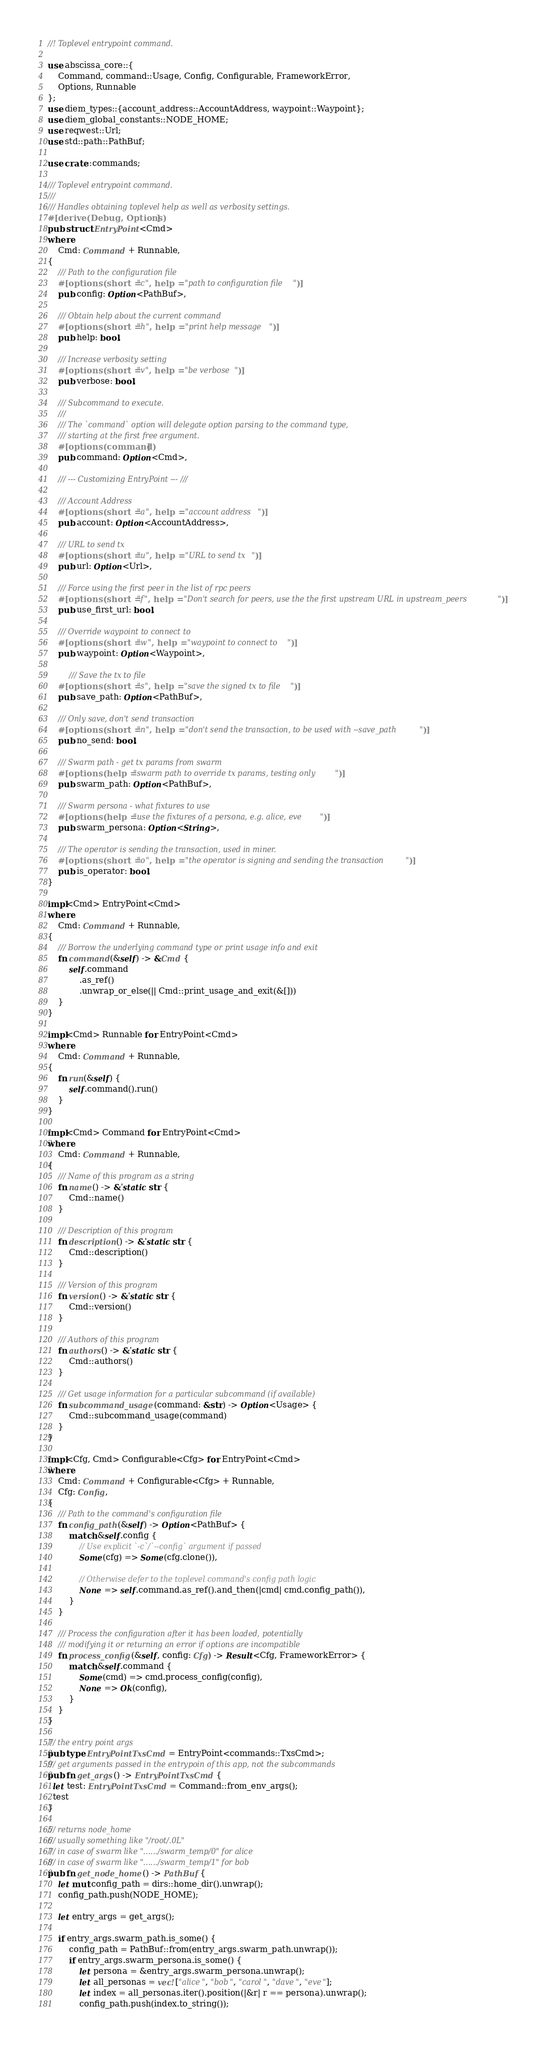Convert code to text. <code><loc_0><loc_0><loc_500><loc_500><_Rust_>//! Toplevel entrypoint command.

use abscissa_core::{
    Command, command::Usage, Config, Configurable, FrameworkError, 
    Options, Runnable    
};
use diem_types::{account_address::AccountAddress, waypoint::Waypoint};
use diem_global_constants::NODE_HOME;
use reqwest::Url;
use std::path::PathBuf;

use crate::commands;

/// Toplevel entrypoint command.
///
/// Handles obtaining toplevel help as well as verbosity settings.
#[derive(Debug, Options)]
pub struct EntryPoint<Cmd>
where
    Cmd: Command + Runnable,
{
    /// Path to the configuration file
    #[options(short = "c", help = "path to configuration file")]
    pub config: Option<PathBuf>,

    /// Obtain help about the current command
    #[options(short = "h", help = "print help message")]
    pub help: bool,

    /// Increase verbosity setting
    #[options(short = "v", help = "be verbose")]
    pub verbose: bool,

    /// Subcommand to execute.
    ///
    /// The `command` option will delegate option parsing to the command type,
    /// starting at the first free argument.
    #[options(command)]
    pub command: Option<Cmd>,

    /// --- Customizing EntryPoint --- ///

    /// Account Address
    #[options(short = "a", help = "account address")]
    pub account: Option<AccountAddress>,

    /// URL to send tx
    #[options(short = "u", help = "URL to send tx")]    
    pub url: Option<Url>,

    /// Force using the first peer in the list of rpc peers
    #[options(short = "f", help = "Don't search for peers, use the the first upstream URL in upstream_peers")]
    pub use_first_url: bool,

    /// Override waypoint to connect to
    #[options(short = "w", help = "waypoint to connect to")]
    pub waypoint: Option<Waypoint>,

        /// Save the tx to file
    #[options(short = "s", help = "save the signed tx to file")]
    pub save_path: Option<PathBuf>,

    /// Only save, don't send transaction
    #[options(short = "n", help = "don't send the transaction, to be used with --save_path")]
    pub no_send: bool,

    /// Swarm path - get tx params from swarm
    #[options(help = "swarm path to override tx params, testing only")]
    pub swarm_path: Option<PathBuf>,

    /// Swarm persona - what fixtures to use
    #[options(help = "use the fixtures of a persona, e.g. alice, eve")]
    pub swarm_persona: Option<String>,

    /// The operator is sending the transaction, used in miner.
    #[options(short = "o", help = "the operator is signing and sending the transaction")]
    pub is_operator: bool,
}

impl<Cmd> EntryPoint<Cmd>
where
    Cmd: Command + Runnable,
{
    /// Borrow the underlying command type or print usage info and exit
    fn command(&self) -> &Cmd {
        self.command
            .as_ref()
            .unwrap_or_else(|| Cmd::print_usage_and_exit(&[]))
    }
}

impl<Cmd> Runnable for EntryPoint<Cmd>
where
    Cmd: Command + Runnable,
{
    fn run(&self) {
        self.command().run()
    }
}

impl<Cmd> Command for EntryPoint<Cmd>
where
    Cmd: Command + Runnable,
{
    /// Name of this program as a string
    fn name() -> &'static str {
        Cmd::name()
    }

    /// Description of this program
    fn description() -> &'static str {
        Cmd::description()
    }

    /// Version of this program
    fn version() -> &'static str {
        Cmd::version()
    }

    /// Authors of this program
    fn authors() -> &'static str {
        Cmd::authors()
    }

    /// Get usage information for a particular subcommand (if available)
    fn subcommand_usage(command: &str) -> Option<Usage> {
        Cmd::subcommand_usage(command)
    }
}

impl<Cfg, Cmd> Configurable<Cfg> for EntryPoint<Cmd>
where
    Cmd: Command + Configurable<Cfg> + Runnable,
    Cfg: Config,
{
    /// Path to the command's configuration file
    fn config_path(&self) -> Option<PathBuf> {
        match &self.config {
            // Use explicit `-c`/`--config` argument if passed
            Some(cfg) => Some(cfg.clone()),

            // Otherwise defer to the toplevel command's config path logic
            None => self.command.as_ref().and_then(|cmd| cmd.config_path()),
        }
    }

    /// Process the configuration after it has been loaded, potentially
    /// modifying it or returning an error if options are incompatible
    fn process_config(&self, config: Cfg) -> Result<Cfg, FrameworkError> {
        match &self.command {
            Some(cmd) => cmd.process_config(config),
            None => Ok(config),
        }
    }
}

/// the entry point args
pub type EntryPointTxsCmd = EntryPoint<commands::TxsCmd>;
/// get arguments passed in the entrypoin of this app, not the subcommands
pub fn get_args() -> EntryPointTxsCmd {
  let test: EntryPointTxsCmd = Command::from_env_args();
  test
}

/// returns node_home
/// usually something like "/root/.0L"
/// in case of swarm like "....../swarm_temp/0" for alice
/// in case of swarm like "....../swarm_temp/1" for bob
pub fn get_node_home() -> PathBuf {
    let mut config_path = dirs::home_dir().unwrap();
    config_path.push(NODE_HOME);

    let entry_args = get_args();

    if entry_args.swarm_path.is_some() {
        config_path = PathBuf::from(entry_args.swarm_path.unwrap());
        if entry_args.swarm_persona.is_some() {
            let persona = &entry_args.swarm_persona.unwrap();
            let all_personas = vec!["alice", "bob", "carol", "dave", "eve"];
            let index = all_personas.iter().position(|&r| r == persona).unwrap();
            config_path.push(index.to_string());</code> 